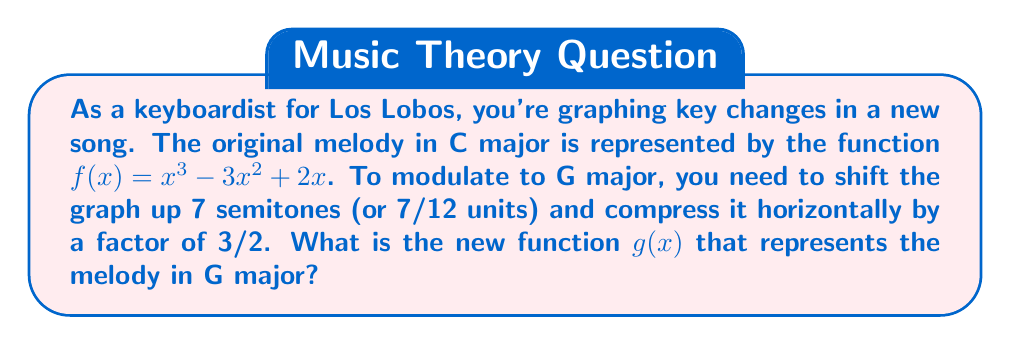Can you answer this question? Let's approach this step-by-step:

1) The original function is $f(x) = x^3 - 3x^2 + 2x$

2) To shift the graph up 7 semitones, we add 7/12 to the function:
   $f(x) + \frac{7}{12}$

3) To compress the graph horizontally by a factor of 3/2, we replace every $x$ with $\frac{3}{2}x$:
   $f(\frac{3}{2}x) + \frac{7}{12}$

4) Now, let's expand this:
   $g(x) = (\frac{3}{2}x)^3 - 3(\frac{3}{2}x)^2 + 2(\frac{3}{2}x) + \frac{7}{12}$

5) Simplify:
   $g(x) = \frac{27}{8}x^3 - \frac{27}{4}x^2 + 3x + \frac{7}{12}$

6) To get common denominators:
   $g(x) = \frac{81}{24}x^3 - \frac{162}{24}x^2 + \frac{72}{24}x + \frac{14}{24}$

Therefore, the new function $g(x)$ that represents the melody in G major is:

$$g(x) = \frac{81}{24}x^3 - \frac{162}{24}x^2 + \frac{72}{24}x + \frac{14}{24}$$
Answer: $g(x) = \frac{81}{24}x^3 - \frac{162}{24}x^2 + \frac{72}{24}x + \frac{14}{24}$ 